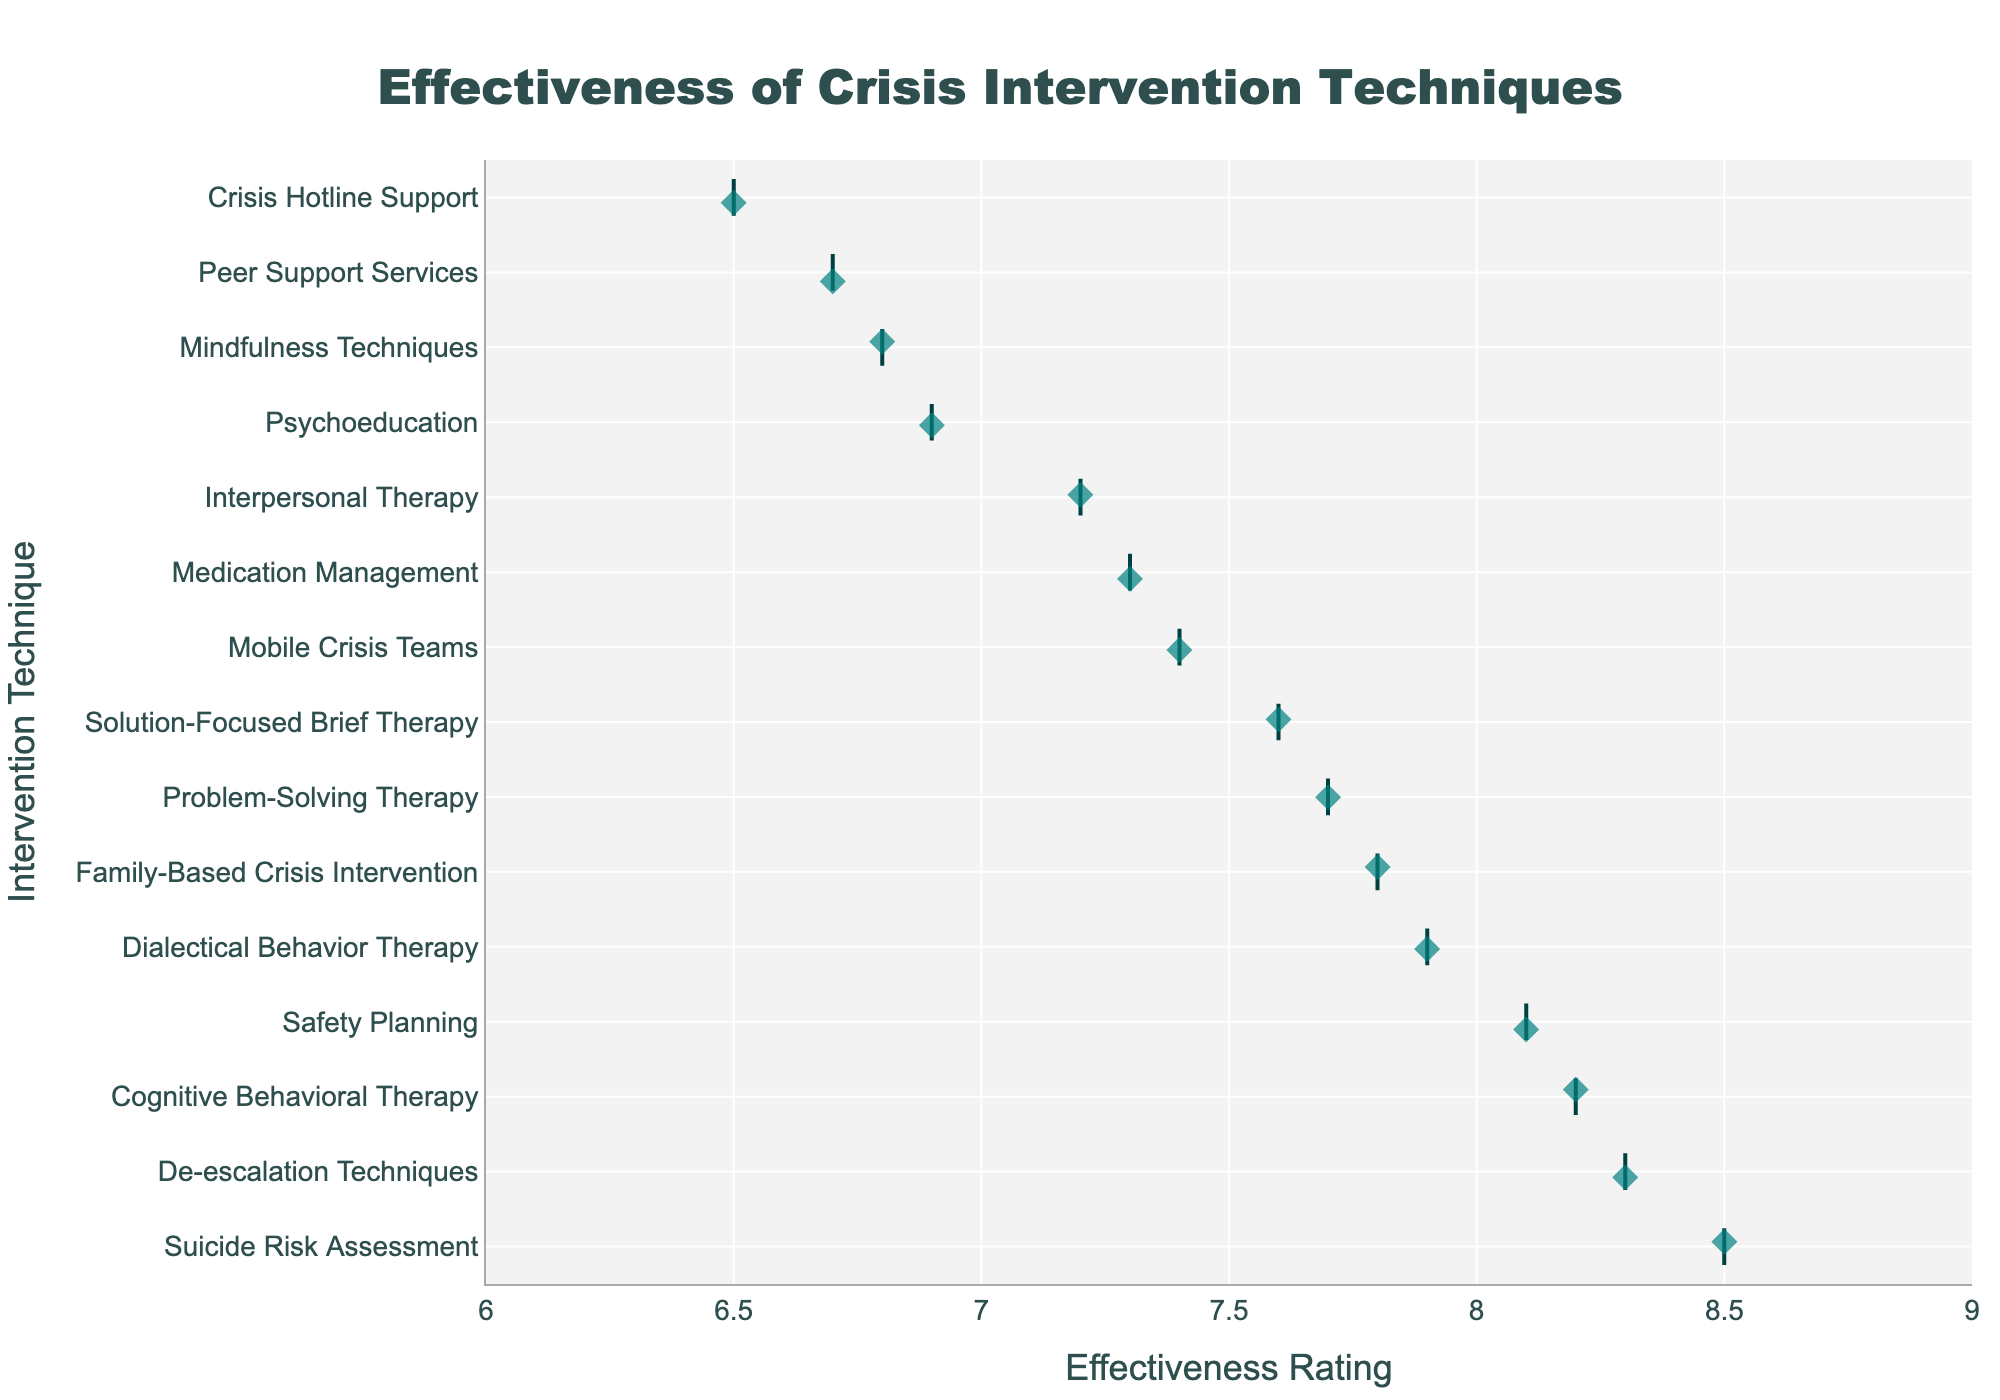What's the title of the figure? The title is located at the top center of the figure; it should be in a larger font and more prominent than other texts.
Answer: Effectiveness of Crisis Intervention Techniques What is the range of the x-axis? The x-axis shows the effectiveness ratings and the range is reflected by checking the minimum and maximum values visible on the axis.
Answer: 6 to 9 Which intervention technique has the highest effectiveness rating? The data points are arranged in descending order; the top-most technique corresponds to the highest rating.
Answer: Suicide Risk Assessment How many intervention techniques have an effectiveness rating of 7.5 or lower? Count the techniques with ratings equal to or below 7.5 by identifying and counting their corresponding points in the plot.
Answer: 7 Compare the effectiveness rating of 'Cognitive Behavioral Therapy' and 'Mindfulness Techniques'. Which one is higher? Locate the ratings for both techniques and compare the values directly.
Answer: Cognitive Behavioral Therapy What is the average effectiveness rating of the techniques shown in the plot? Sum all the effectiveness ratings and divide by the total number of techniques to calculate the average.
Answer: 7.5 Which techniques have an effectiveness rating greater than 'Mobile Crisis Teams' but less than 'Safety Planning'? Identify the ratings for 'Mobile Crisis Teams' and 'Safety Planning', then find the techniques that fall in the range between these two ratings.
Answer: Family-Based Crisis Intervention, Problem-Solving Therapy, Solution-Focused Brief Therapy What is the difference in effectiveness ratings between 'De-escalation Techniques' and 'Interpersonal Therapy'? Subtract the effectiveness rating of 'Interpersonal Therapy' from that of 'De-escalation Techniques'.
Answer: 1.1 Are Mobile Crisis Teams rated higher or lower than Medication Management? Compare the effectiveness ratings of both techniques by looking at their positions on the plot.
Answer: Higher 